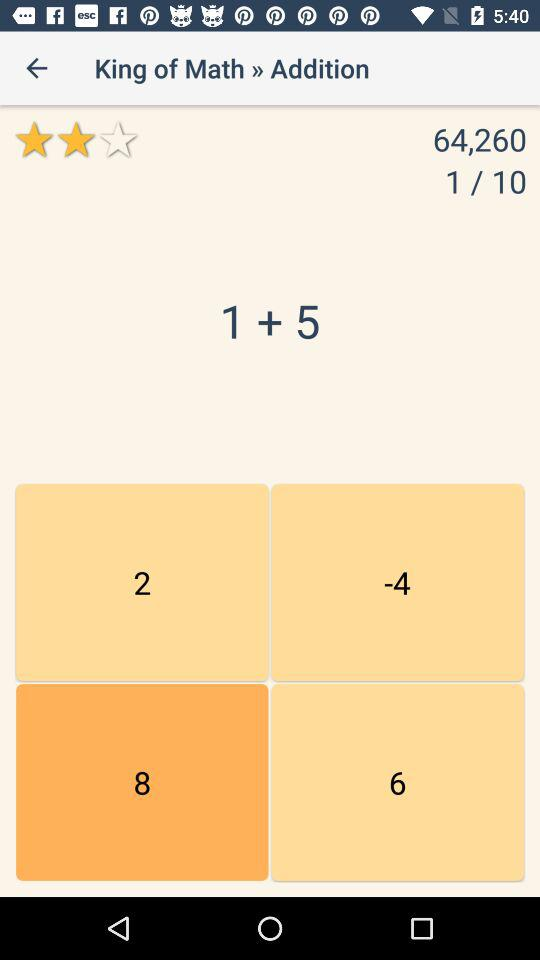How long does the user have to answer the question?
When the provided information is insufficient, respond with <no answer>. <no answer> 